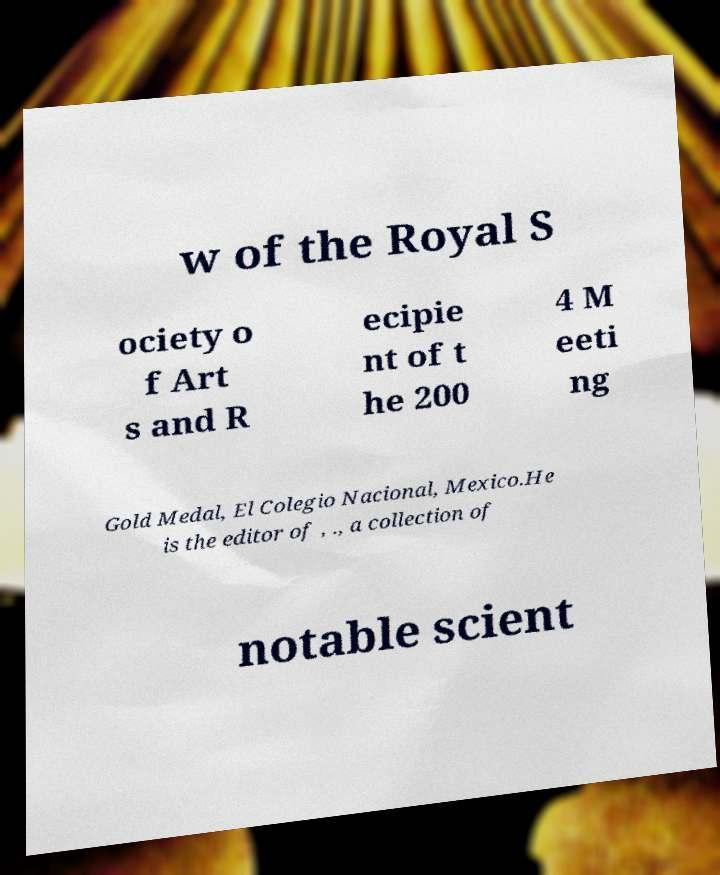For documentation purposes, I need the text within this image transcribed. Could you provide that? w of the Royal S ociety o f Art s and R ecipie nt of t he 200 4 M eeti ng Gold Medal, El Colegio Nacional, Mexico.He is the editor of , ., a collection of notable scient 